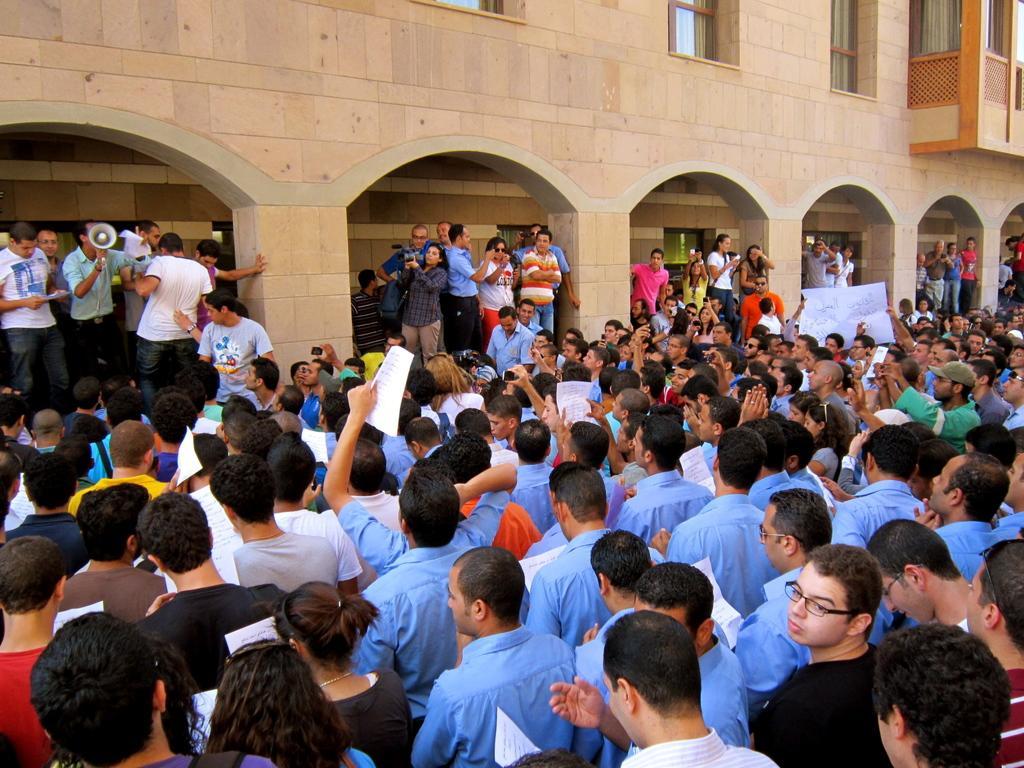Describe this image in one or two sentences. People are standing holding papers. There is a building and a person is holding a mouth speaker. 